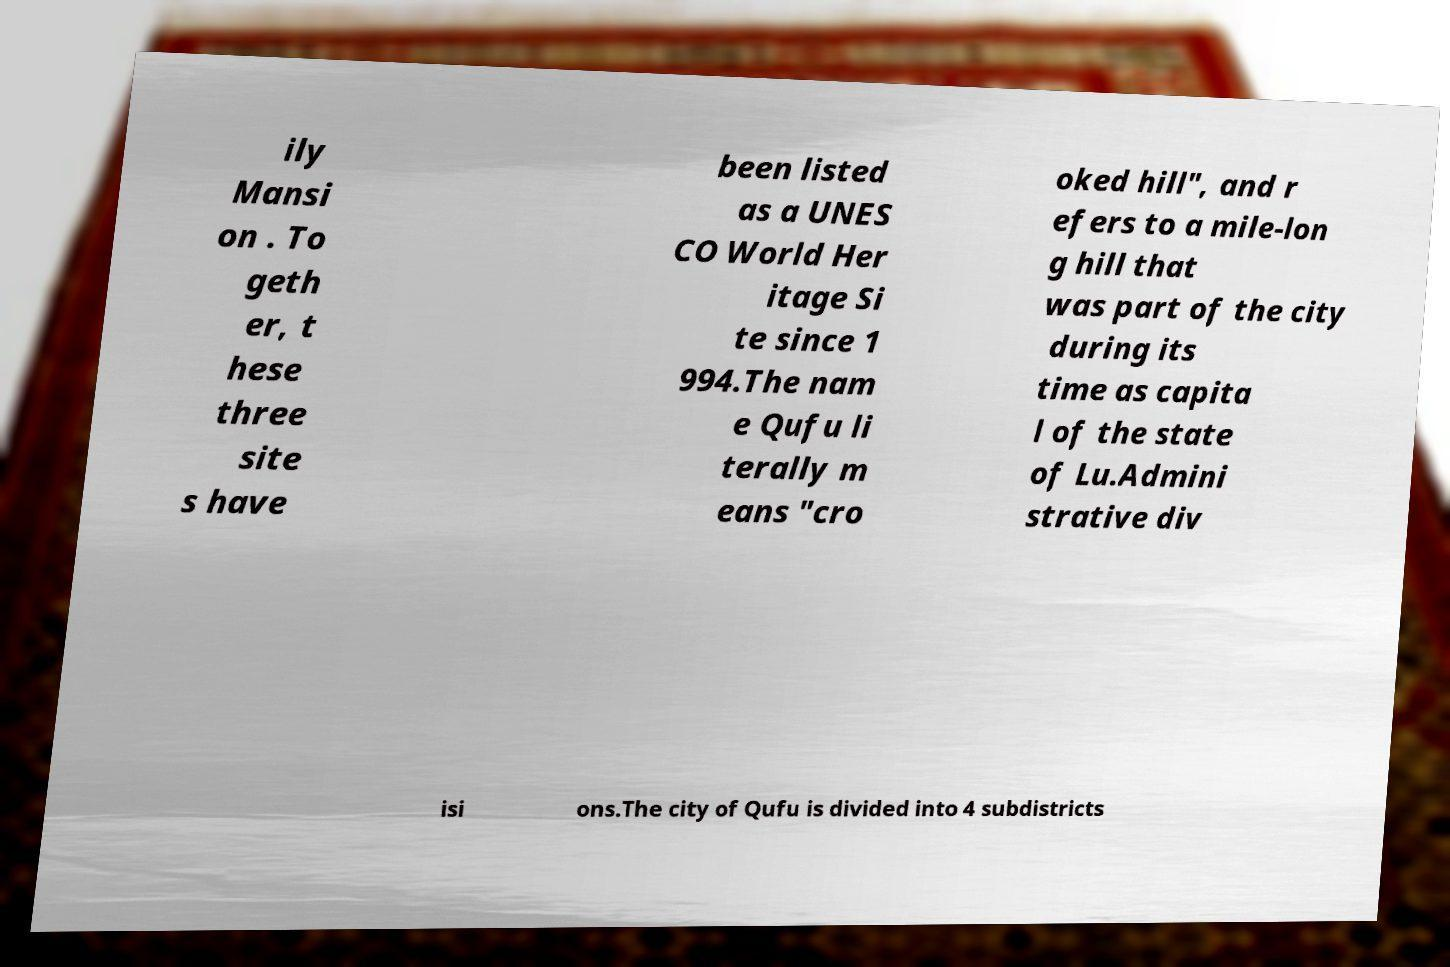Can you accurately transcribe the text from the provided image for me? ily Mansi on . To geth er, t hese three site s have been listed as a UNES CO World Her itage Si te since 1 994.The nam e Qufu li terally m eans "cro oked hill", and r efers to a mile-lon g hill that was part of the city during its time as capita l of the state of Lu.Admini strative div isi ons.The city of Qufu is divided into 4 subdistricts 